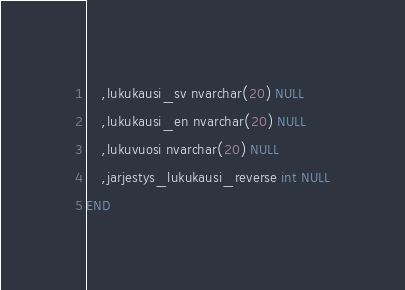Convert code to text. <code><loc_0><loc_0><loc_500><loc_500><_SQL_>	,lukukausi_sv nvarchar(20) NULL
	,lukukausi_en nvarchar(20) NULL
	,lukuvuosi nvarchar(20) NULL
	,jarjestys_lukukausi_reverse int NULL
END</code> 